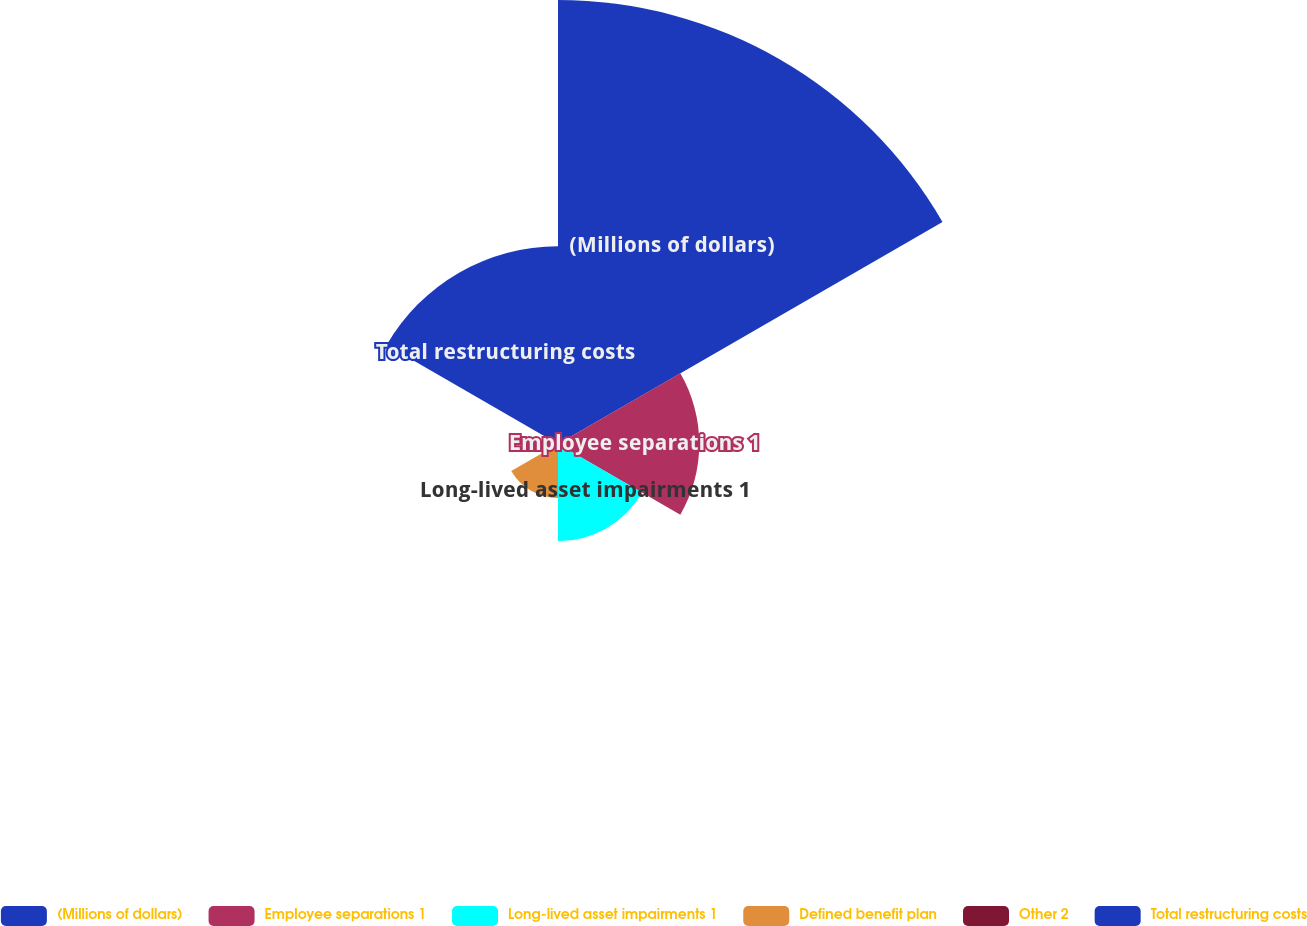<chart> <loc_0><loc_0><loc_500><loc_500><pie_chart><fcel>(Millions of dollars)<fcel>Employee separations 1<fcel>Long-lived asset impairments 1<fcel>Defined benefit plan<fcel>Other 2<fcel>Total restructuring costs<nl><fcel>46.99%<fcel>14.95%<fcel>10.29%<fcel>5.71%<fcel>1.12%<fcel>20.94%<nl></chart> 